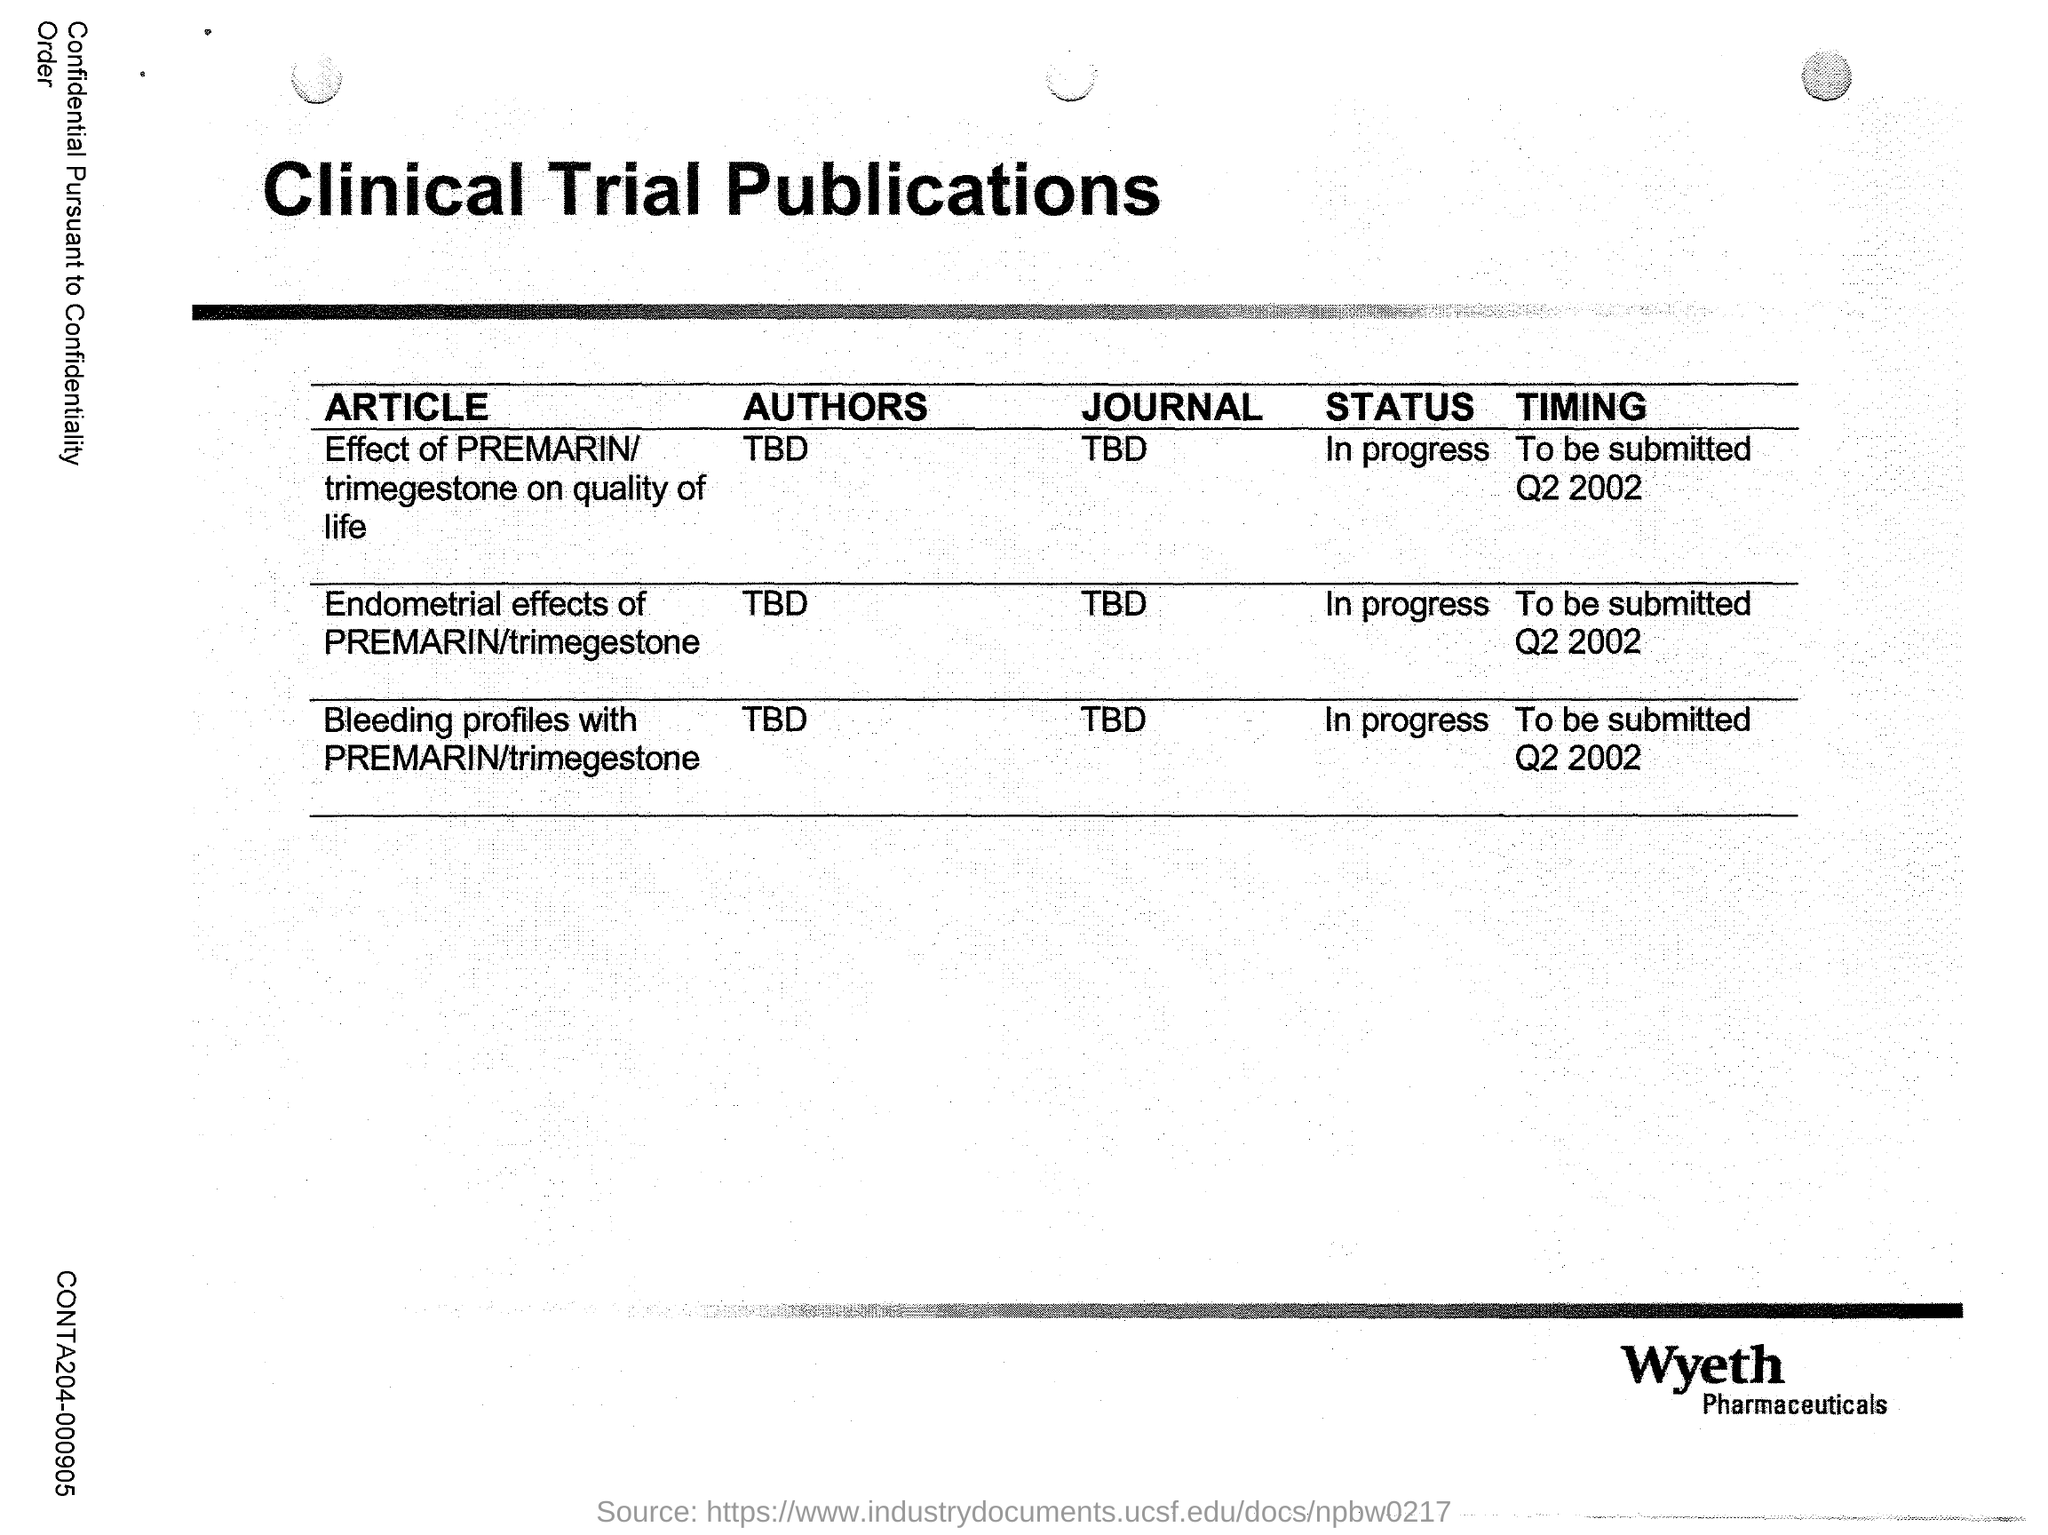Mention a couple of crucial points in this snapshot. The title of this document is "Clinical Trial Publications. The clinical trial publications in question are from a pharmaceutical company called Wyeth. The article titled "Endometrial effects of PREMARIN/trimegestone" is currently in progress. The author of the article titled "Endometrial effects of PREMARIN/trimegestone" is unknown at this time. 